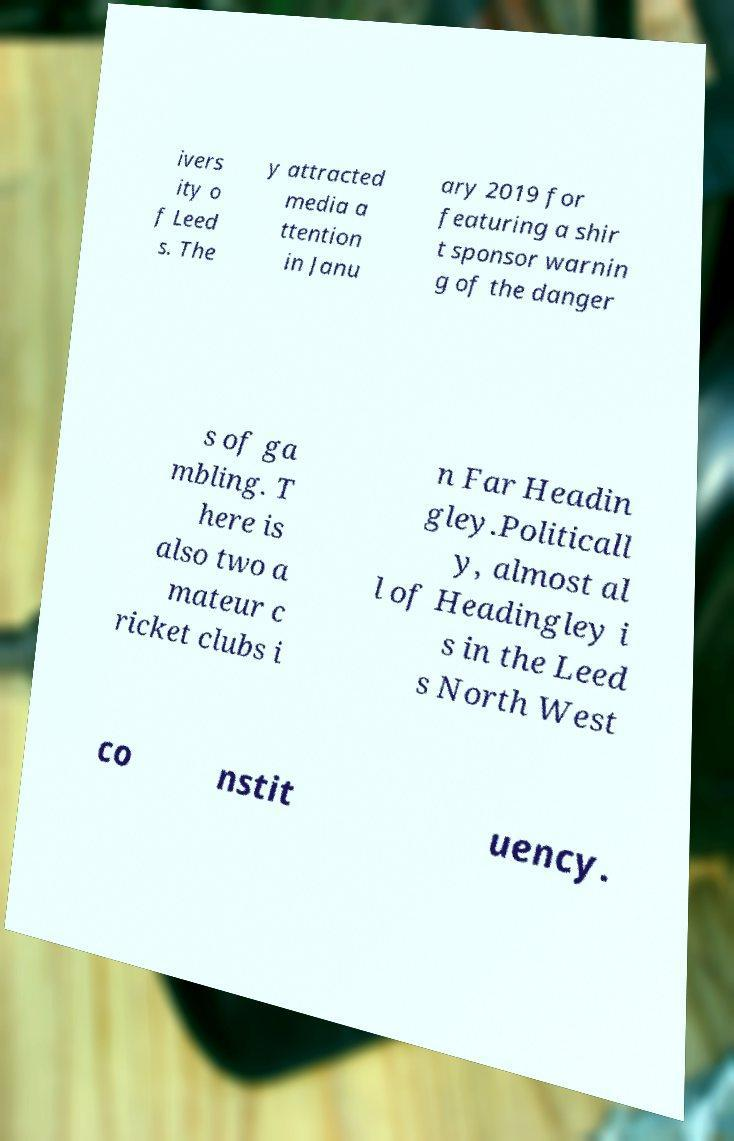Please identify and transcribe the text found in this image. ivers ity o f Leed s. The y attracted media a ttention in Janu ary 2019 for featuring a shir t sponsor warnin g of the danger s of ga mbling. T here is also two a mateur c ricket clubs i n Far Headin gley.Politicall y, almost al l of Headingley i s in the Leed s North West co nstit uency. 